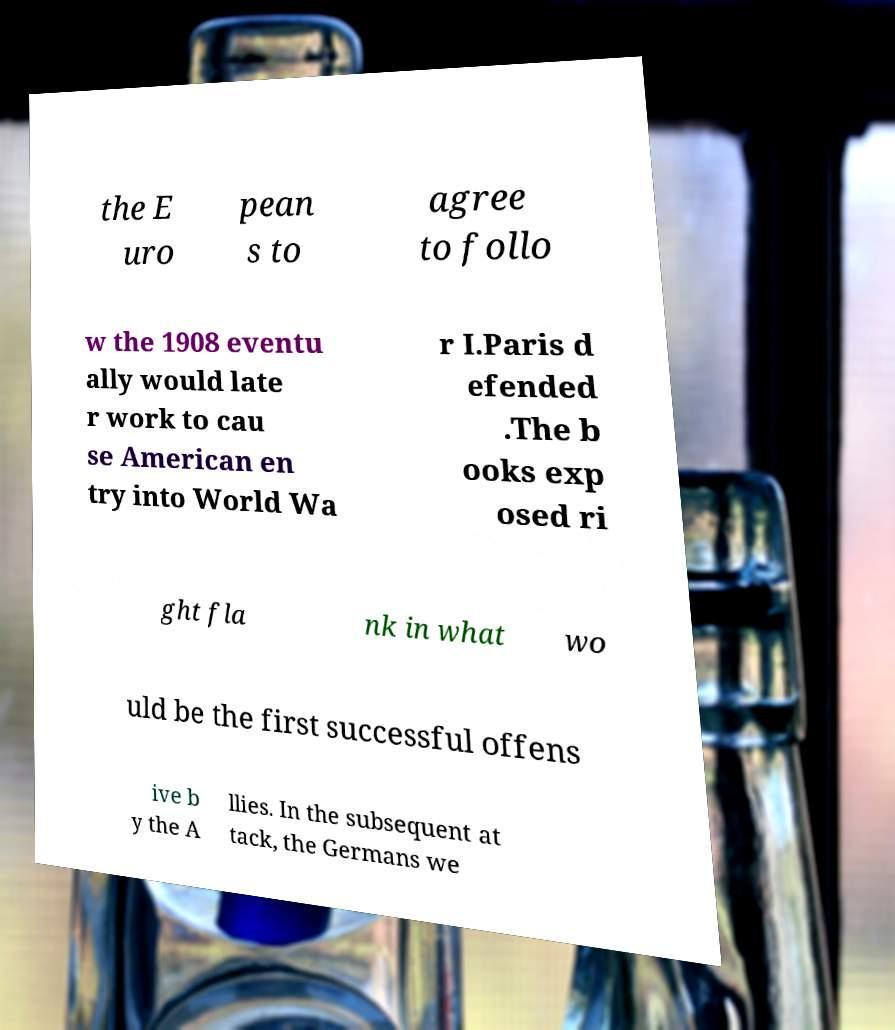For documentation purposes, I need the text within this image transcribed. Could you provide that? the E uro pean s to agree to follo w the 1908 eventu ally would late r work to cau se American en try into World Wa r I.Paris d efended .The b ooks exp osed ri ght fla nk in what wo uld be the first successful offens ive b y the A llies. In the subsequent at tack, the Germans we 